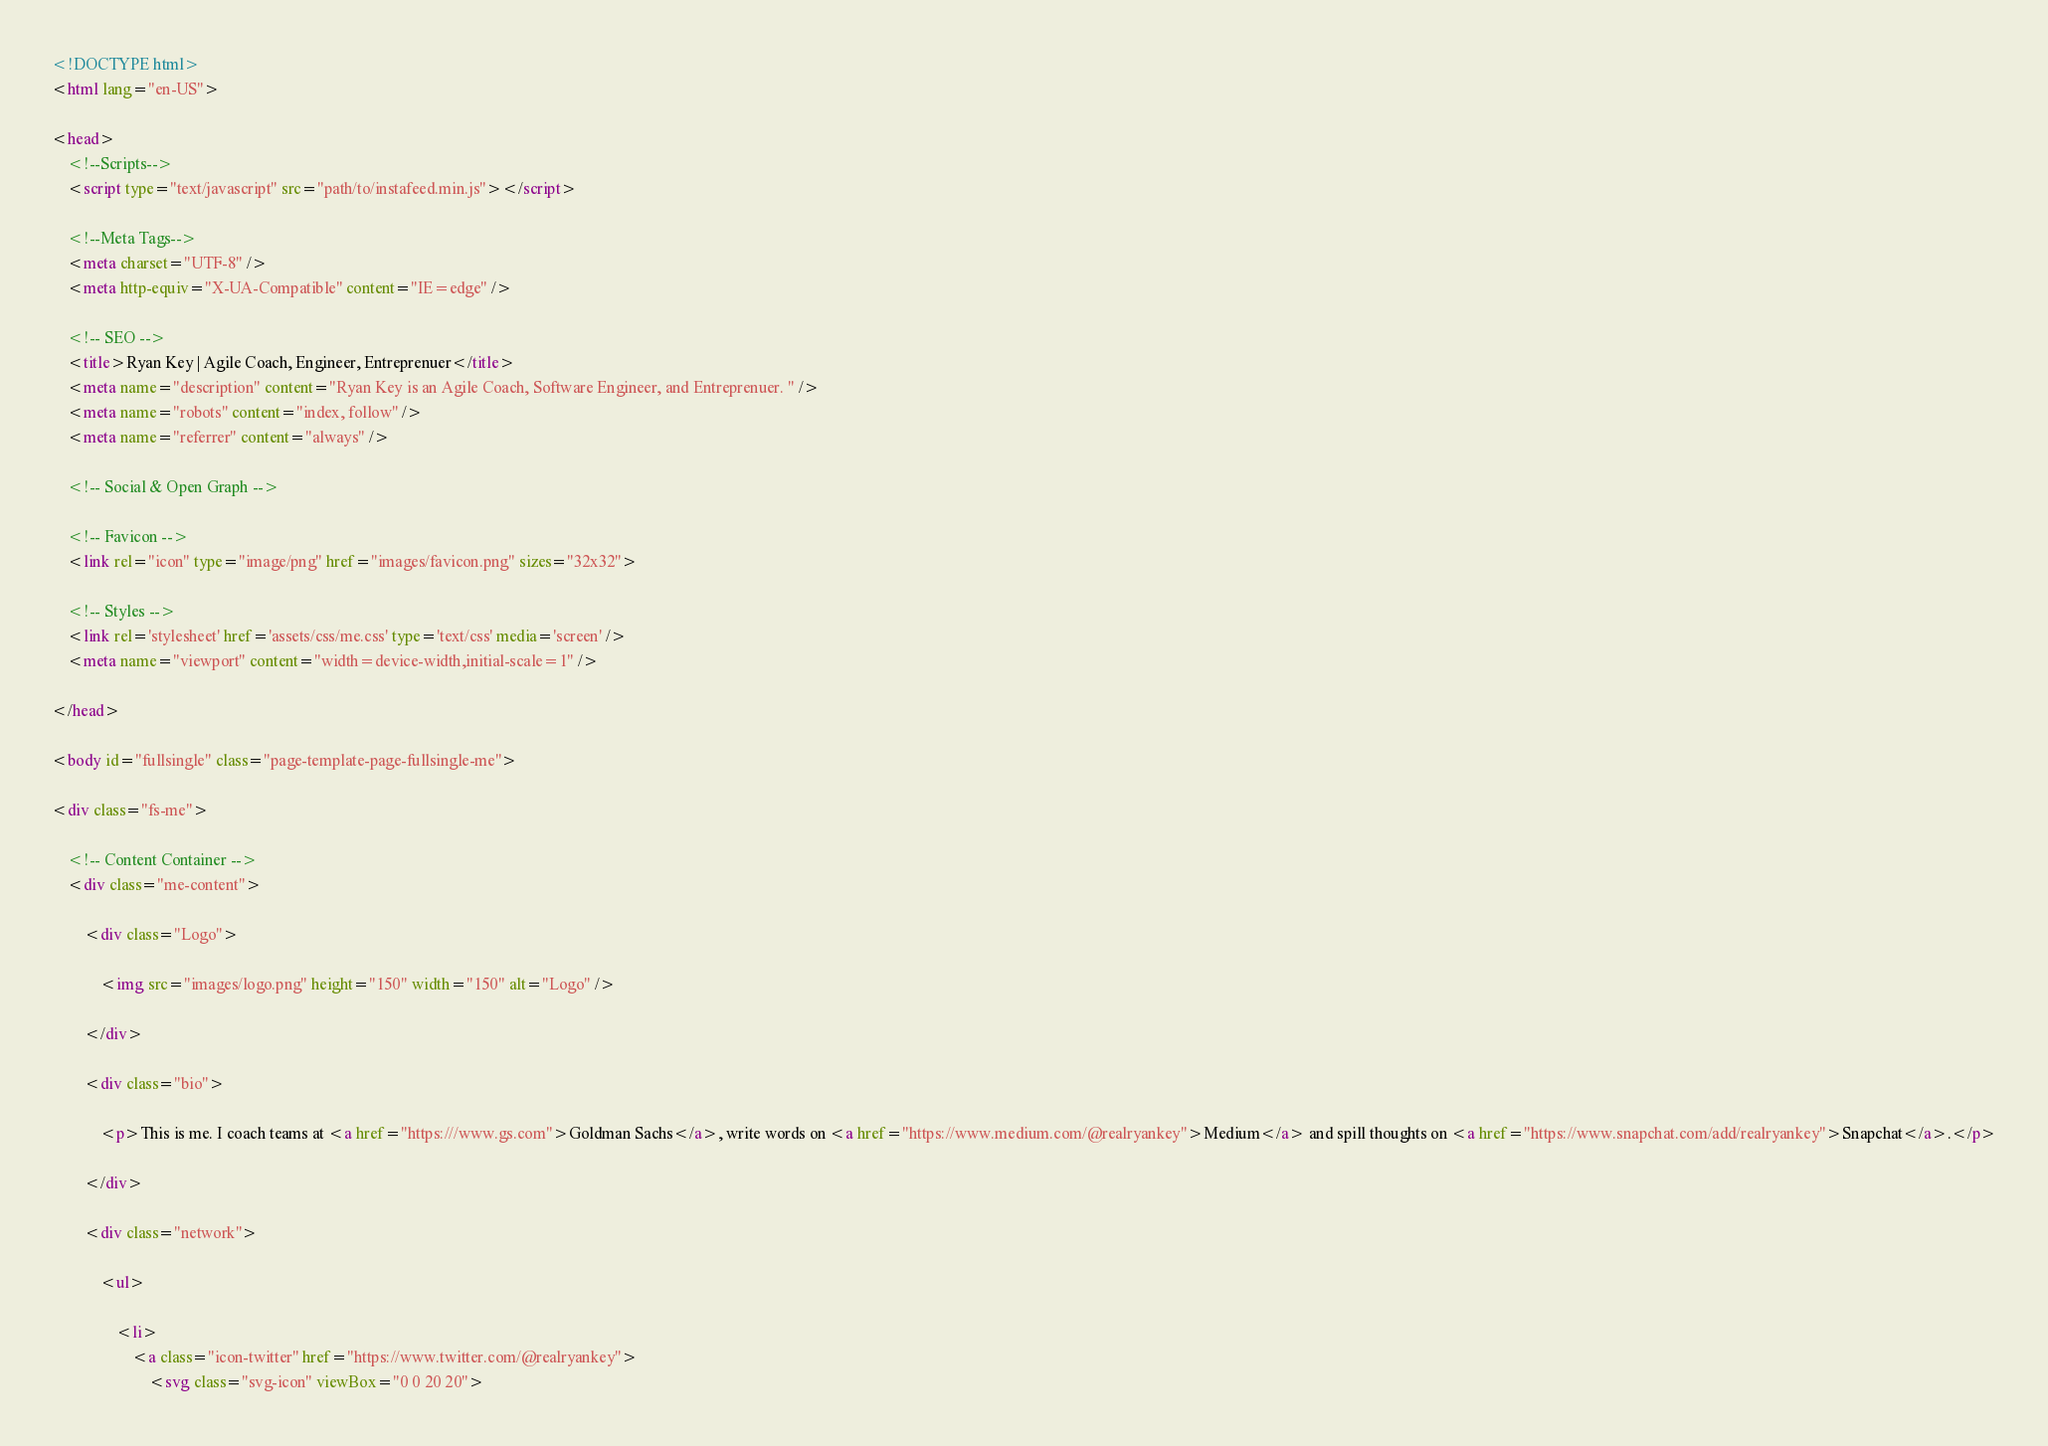Convert code to text. <code><loc_0><loc_0><loc_500><loc_500><_HTML_><!DOCTYPE html>
<html lang="en-US">

<head>
	<!--Scripts-->
	<script type="text/javascript" src="path/to/instafeed.min.js"></script>

	<!--Meta Tags-->
	<meta charset="UTF-8" />
	<meta http-equiv="X-UA-Compatible" content="IE=edge" />

	<!-- SEO -->
	<title>Ryan Key | Agile Coach, Engineer, Entreprenuer</title>
	<meta name="description" content="Ryan Key is an Agile Coach, Software Engineer, and Entreprenuer. " />
	<meta name="robots" content="index, follow" />
	<meta name="referrer" content="always" />

	<!-- Social & Open Graph -->

	<!-- Favicon -->
	<link rel="icon" type="image/png" href="images/favicon.png" sizes="32x32">

	<!-- Styles -->
	<link rel='stylesheet' href='assets/css/me.css' type='text/css' media='screen' />
	<meta name="viewport" content="width=device-width,initial-scale=1" />

</head>

<body id="fullsingle" class="page-template-page-fullsingle-me">

<div class="fs-me">

	<!-- Content Container -->
	<div class="me-content">

		<div class="Logo">

			<img src="images/logo.png" height="150" width="150" alt="Logo" />

		</div>

		<div class="bio">

			<p>This is me. I coach teams at <a href="https:///www.gs.com">Goldman Sachs</a>, write words on <a href="https://www.medium.com/@realryankey">Medium</a> and spill thoughts on <a href="https://www.snapchat.com/add/realryankey">Snapchat</a>.</p>

		</div>

		<div class="network">

			<ul>

				<li>
					<a class="icon-twitter" href="https://www.twitter.com/@realryankey">
						<svg class="svg-icon" viewBox="0 0 20 20"></code> 